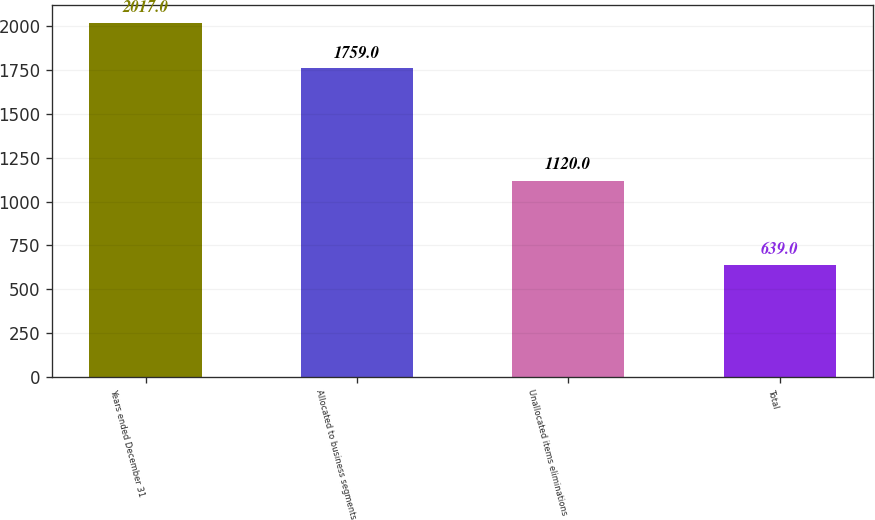Convert chart to OTSL. <chart><loc_0><loc_0><loc_500><loc_500><bar_chart><fcel>Years ended December 31<fcel>Allocated to business segments<fcel>Unallocated items eliminations<fcel>Total<nl><fcel>2017<fcel>1759<fcel>1120<fcel>639<nl></chart> 